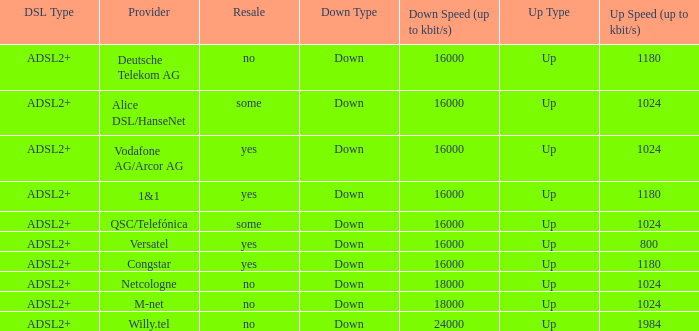What is the resale category for the provider NetCologne? No. 